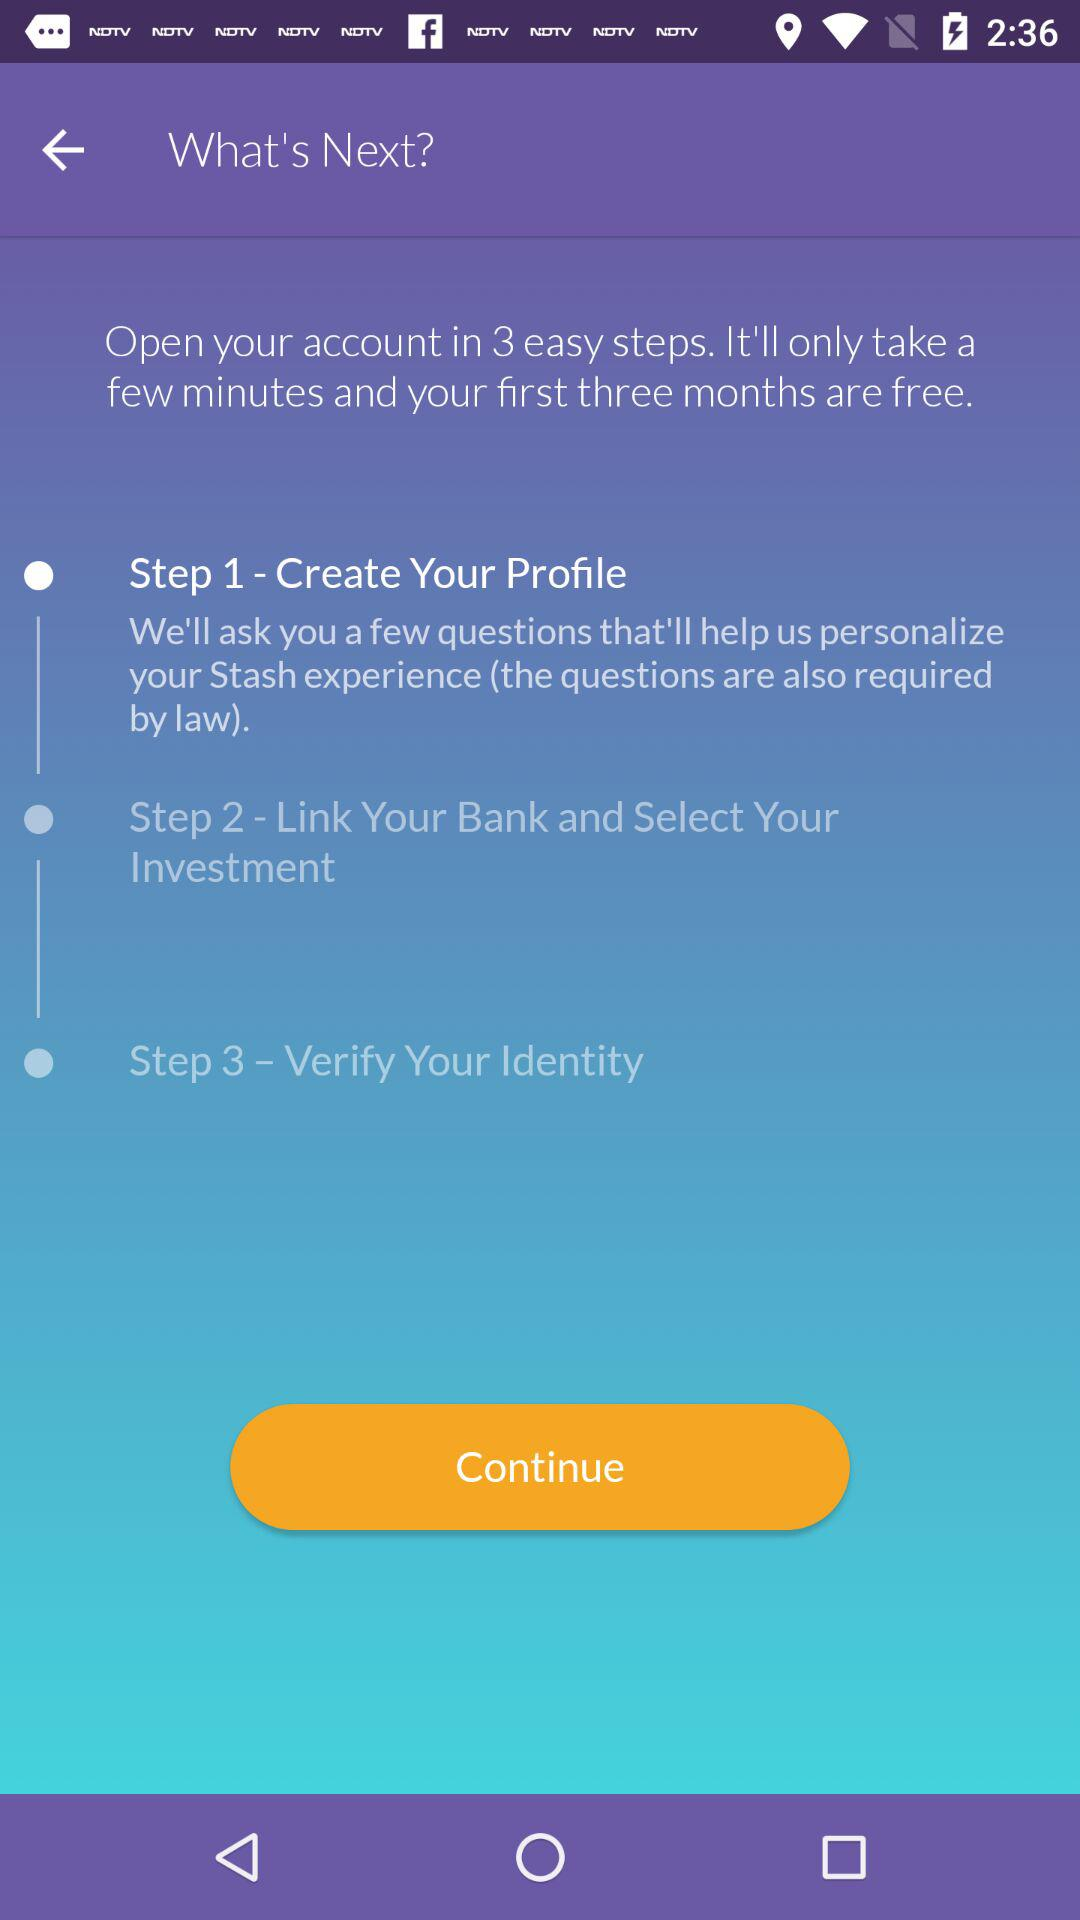How much is the account fee after the first three months?
When the provided information is insufficient, respond with <no answer>. <no answer> 